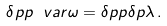Convert formula to latex. <formula><loc_0><loc_0><loc_500><loc_500>\delta p p \ v a r \omega = \delta p p \delta p \lambda \, .</formula> 